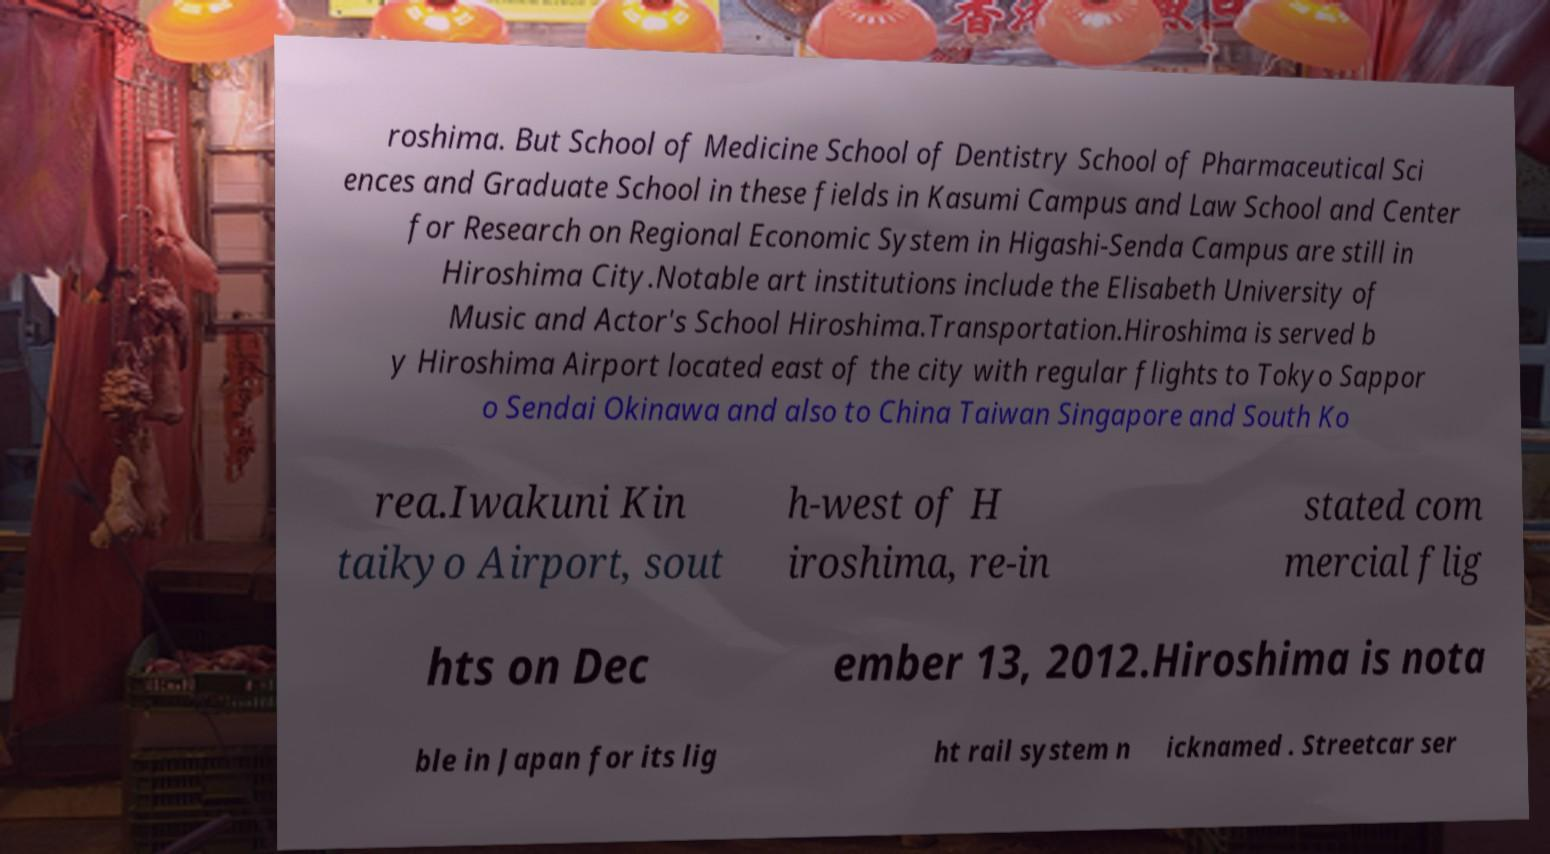What messages or text are displayed in this image? I need them in a readable, typed format. roshima. But School of Medicine School of Dentistry School of Pharmaceutical Sci ences and Graduate School in these fields in Kasumi Campus and Law School and Center for Research on Regional Economic System in Higashi-Senda Campus are still in Hiroshima City.Notable art institutions include the Elisabeth University of Music and Actor's School Hiroshima.Transportation.Hiroshima is served b y Hiroshima Airport located east of the city with regular flights to Tokyo Sappor o Sendai Okinawa and also to China Taiwan Singapore and South Ko rea.Iwakuni Kin taikyo Airport, sout h-west of H iroshima, re-in stated com mercial flig hts on Dec ember 13, 2012.Hiroshima is nota ble in Japan for its lig ht rail system n icknamed . Streetcar ser 